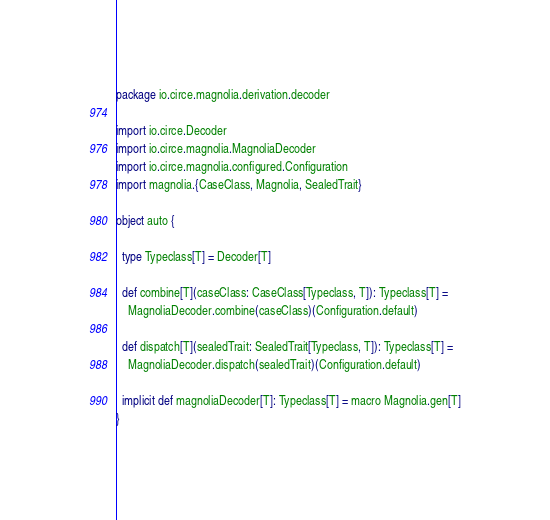<code> <loc_0><loc_0><loc_500><loc_500><_Scala_>package io.circe.magnolia.derivation.decoder

import io.circe.Decoder
import io.circe.magnolia.MagnoliaDecoder
import io.circe.magnolia.configured.Configuration
import magnolia.{CaseClass, Magnolia, SealedTrait}

object auto {

  type Typeclass[T] = Decoder[T]

  def combine[T](caseClass: CaseClass[Typeclass, T]): Typeclass[T] =
    MagnoliaDecoder.combine(caseClass)(Configuration.default)

  def dispatch[T](sealedTrait: SealedTrait[Typeclass, T]): Typeclass[T] =
    MagnoliaDecoder.dispatch(sealedTrait)(Configuration.default)

  implicit def magnoliaDecoder[T]: Typeclass[T] = macro Magnolia.gen[T]
}
</code> 